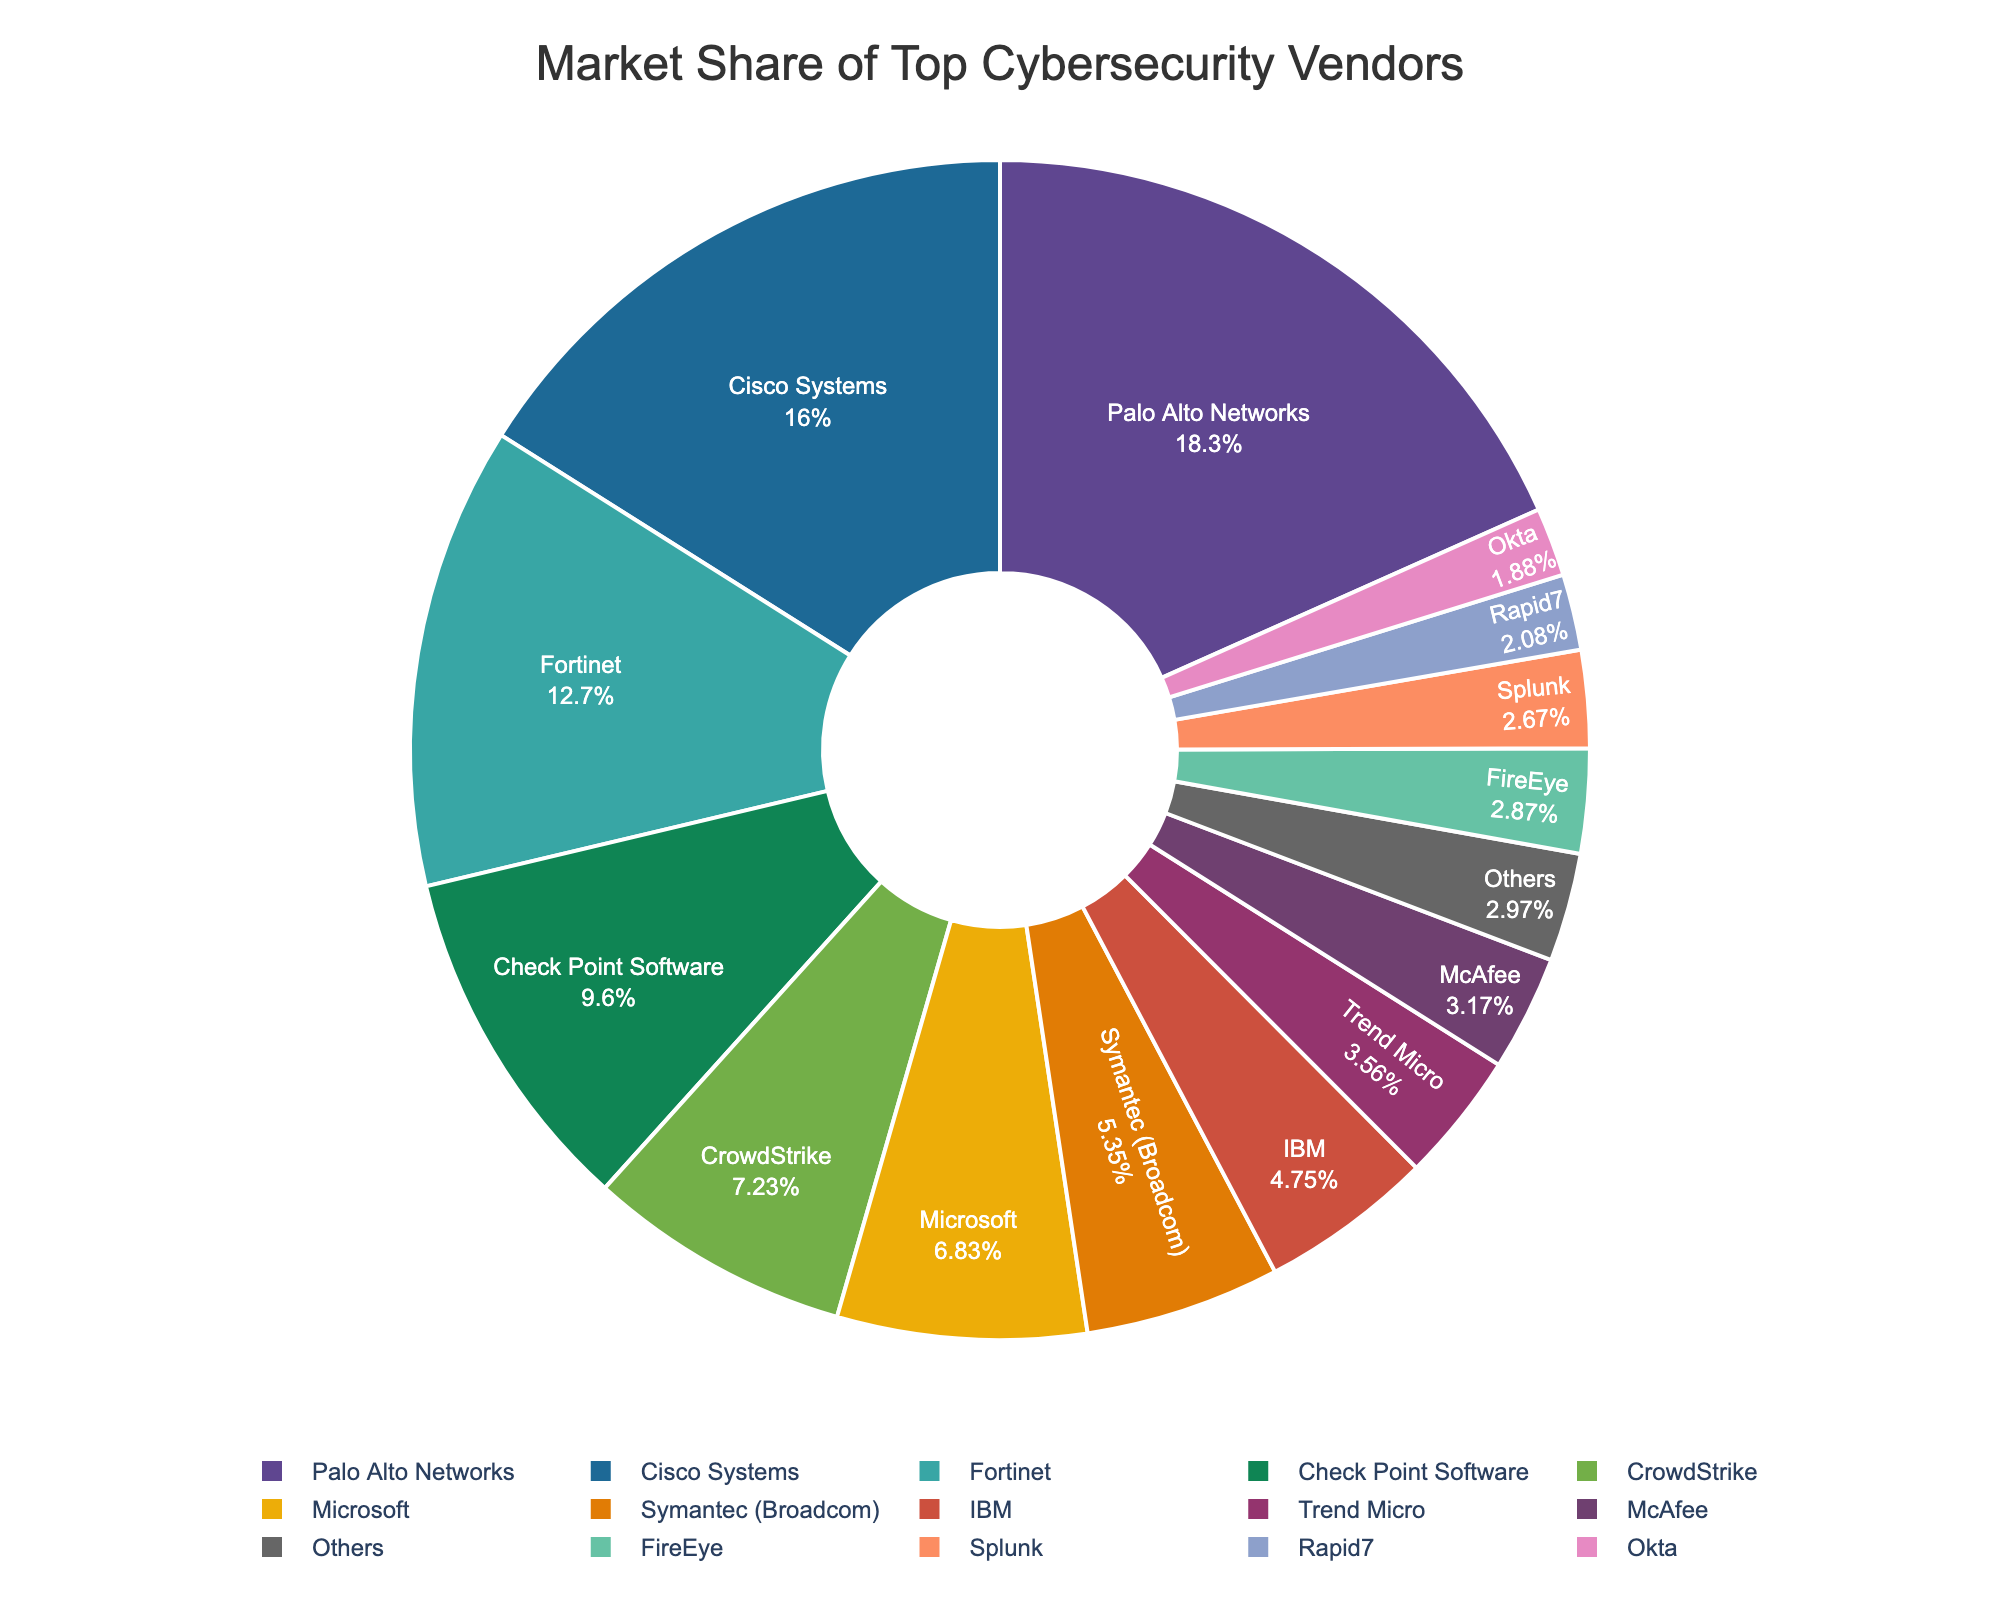What is the market share of Cisco Systems? Referring to the pie chart, Cisco Systems holds 16.2% of the market share in the enterprise cybersecurity sector.
Answer: 16.2% Which vendor has the smallest market share among the top 14 listed vendors? By examining the slices of the pie chart, Okta has the smallest market share among the top 14 listed vendors, with 1.9%.
Answer: Okta What is the total market share held by the top three vendors? The top three vendors are Palo Alto Networks (18.5%), Cisco Systems (16.2%), and Fortinet (12.8%). Summing these percentages: 18.5 + 16.2 + 12.8 = 47.5%.
Answer: 47.5% How does the market share of Palo Alto Networks compare to that of Fortinet? Palo Alto Networks holds 18.5% of the market share, while Fortinet holds 12.8%. Comparing these values, Palo Alto Networks has a higher market share than Fortinet.
Answer: Palo Alto Networks has a higher market share What is the combined market share of Check Point Software and CrowdStrike? Check Point Software holds 9.7% and CrowdStrike holds 7.3%. Adding these together: 9.7 + 7.3 = 17%.
Answer: 17% Which vendor has a higher market share, Microsoft or Symantec (Broadcom)? By referring to the pie chart, Microsoft has a market share of 6.9%, while Symantec (Broadcom) has 5.4%. Thus, Microsoft has a higher market share.
Answer: Microsoft How does the market share of McAfee compare to that of IBM? McAfee has a market share of 3.2%, while IBM has 4.8%. The market share of IBM is higher than that of McAfee.
Answer: IBM has a higher market share What is the difference in market share between FireEye and Splunk? FireEye holds 2.9% of the market share, while Splunk holds 2.7%. The difference in market share between FireEye and Splunk: 2.9 - 2.7 = 0.2%.
Answer: 0.2% What is the total market share of vendors with less than a 5% market share individually? Vendors with less than 5% market share are Symantec (Broadcom) (5.4%), IBM (4.8%), Trend Micro (3.6%), McAfee (3.2%), FireEye (2.9%), Splunk (2.7%), Rapid7 (2.1%), Okta (1.9%), and "Others" (3.0%). Adding these together: 4.8 + 3.6 + 3.2 + 2.9 + 2.7 + 2.1 + 1.9 + 3.0 = 24.2% (excluding Symantec as it is over 5%).
Answer: 24.2% What color represents CrowdStrike in the pie chart? Based on the pie chart, the slice representing CrowdStrike can be identified by its specific color. From the data, CrowdStrike is represented by the color matching its designated slice.
Answer: (specific color based on the chart) 